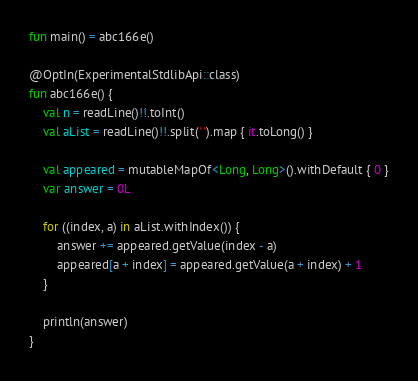<code> <loc_0><loc_0><loc_500><loc_500><_Kotlin_>fun main() = abc166e()

@OptIn(ExperimentalStdlibApi::class)
fun abc166e() {
    val n = readLine()!!.toInt()
    val aList = readLine()!!.split(' ').map { it.toLong() }

    val appeared = mutableMapOf<Long, Long>().withDefault { 0 }
    var answer = 0L

    for ((index, a) in aList.withIndex()) {
        answer += appeared.getValue(index - a)
        appeared[a + index] = appeared.getValue(a + index) + 1
    }

    println(answer)
}
</code> 